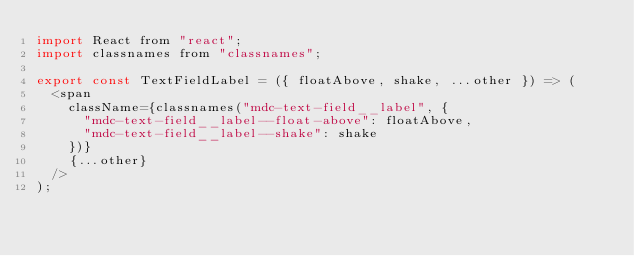<code> <loc_0><loc_0><loc_500><loc_500><_JavaScript_>import React from "react";
import classnames from "classnames";

export const TextFieldLabel = ({ floatAbove, shake, ...other }) => (
  <span
    className={classnames("mdc-text-field__label", {
      "mdc-text-field__label--float-above": floatAbove,
      "mdc-text-field__label--shake": shake
    })}
    {...other}
  />
);
</code> 